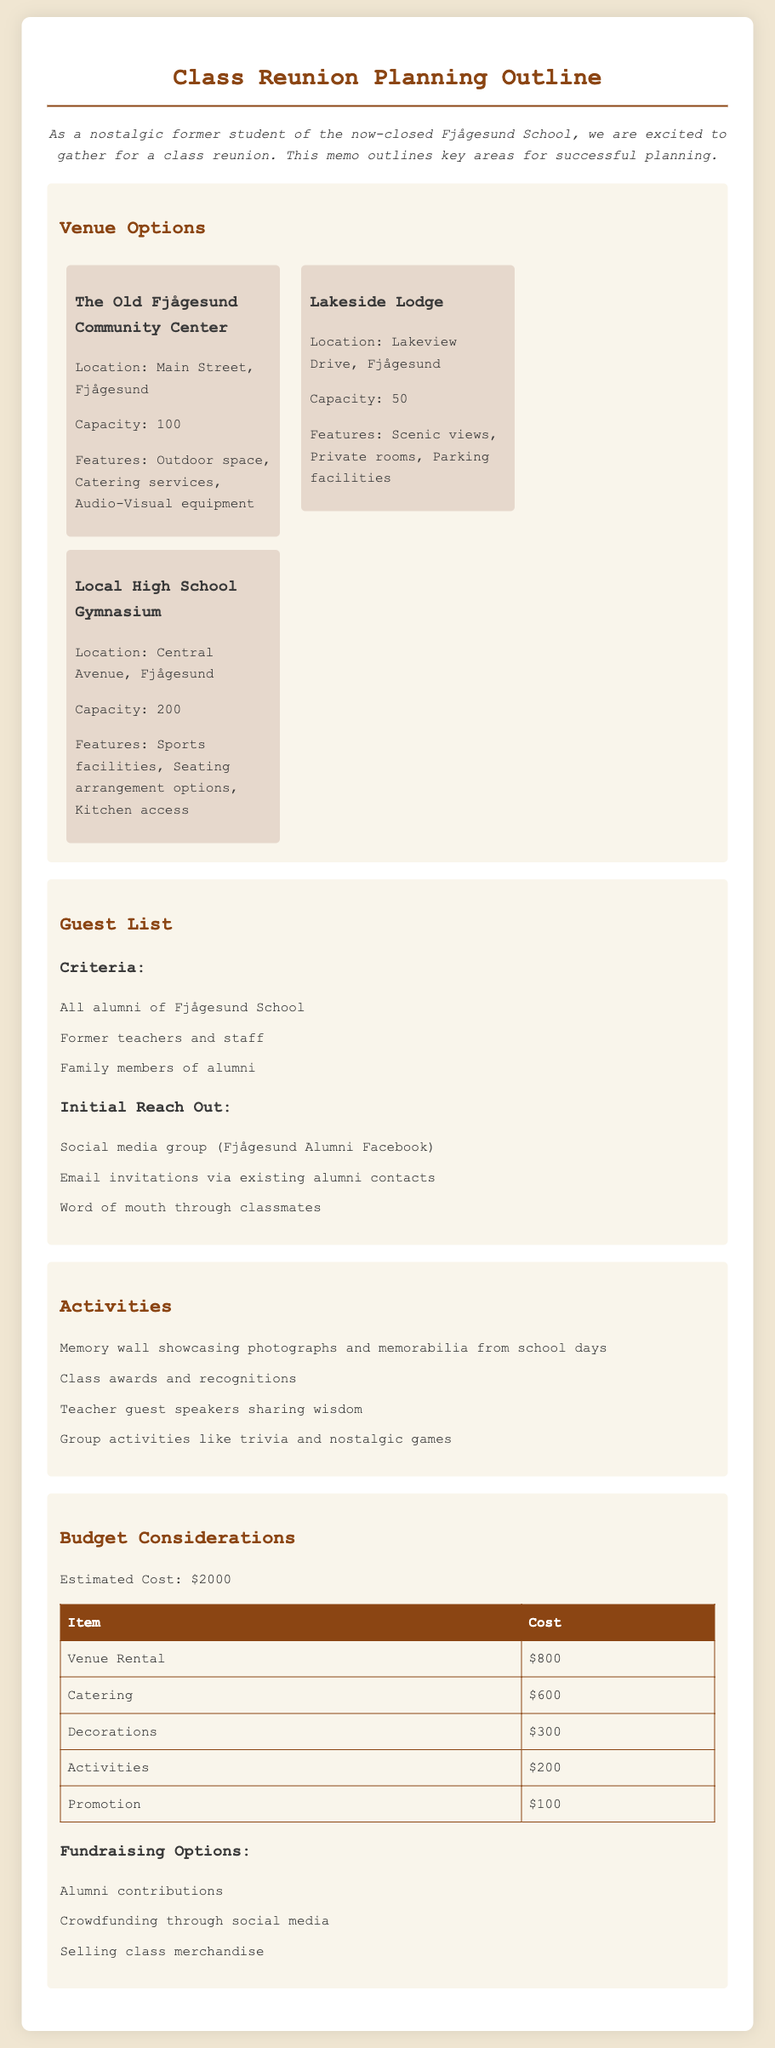What is the name of the first venue option? The first venue listed under Venue Options is "The Old Fjågesund Community Center."
Answer: The Old Fjågesund Community Center What is the capacity of the Local High School Gymnasium? The capacity of the Local High School Gymnasium is mentioned in the document as 200.
Answer: 200 What is the total estimated cost for the reunion? The total estimated cost for the reunion is specified as $2000.
Answer: $2000 How many activities are listed in the document? The document lists a total of four activities in the Activities section.
Answer: 4 What method is suggested for reaching out to alumni? Social media group (Fjågesund Alumni Facebook) is one suggested method for reaching out to alumni.
Answer: Social media group (Fjågesund Alumni Facebook) What item has the highest cost in the budget? "Venue Rental" is the item with the highest cost listed in the budget.
Answer: Venue Rental What feature does the Lakeside Lodge offer? One of the features of the Lakeside Lodge is "Scenic views."
Answer: Scenic views What is one fundraising option mentioned in the budget considerations? "Alumni contributions" is one of the fundraising options mentioned.
Answer: Alumni contributions What is the main purpose of this document? The main purpose of the document is to outline planning for a class reunion.
Answer: Outline planning for a class reunion 